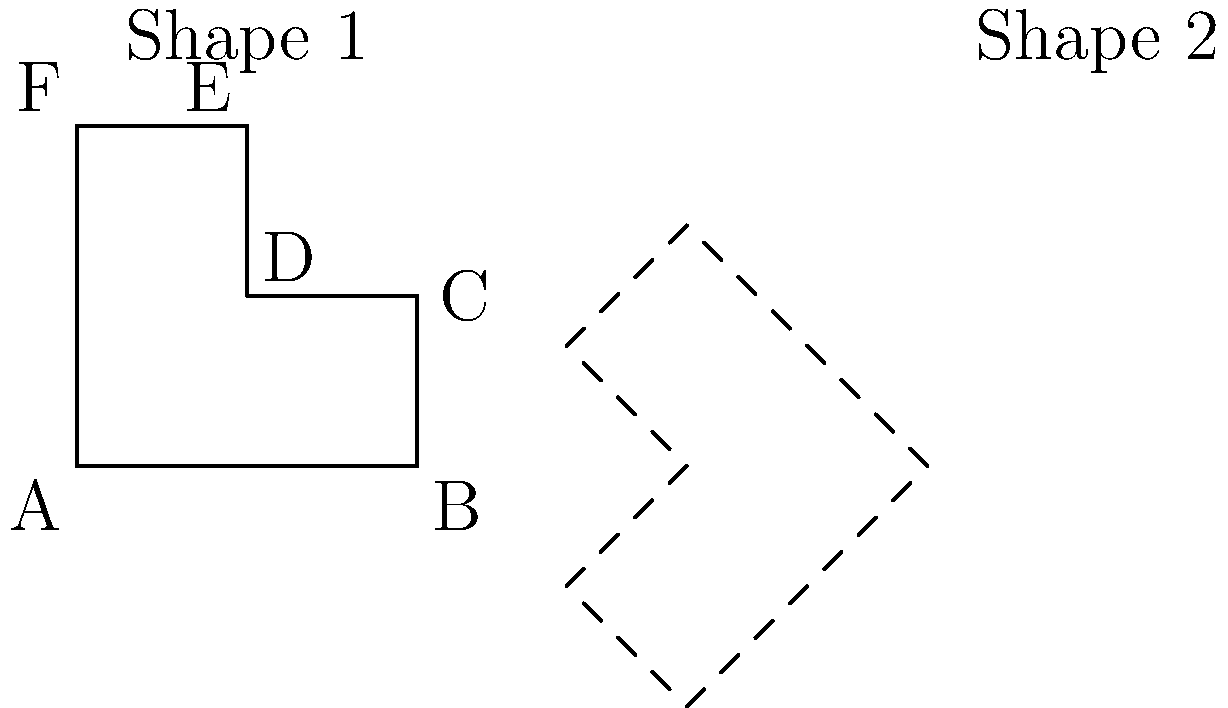Shape 1 is rotated to create Shape 2. What is the angle of rotation in degrees? To determine the angle of rotation, let's follow these steps:

1. Observe the orientation of both shapes. Shape 1 is upright, while Shape 2 is rotated counterclockwise.

2. Look for a key feature that can help identify the rotation. In this case, the long edge of the shape (side AB in Shape 1) is a good reference.

3. In Shape 1, side AB is horizontal. In Shape 2, this side is now diagonal, pointing towards the upper-left corner.

4. The rotation that transforms a horizontal line to a diagonal line pointing up and left is 135°.

5. To verify, we can check other features:
   - The right angle at point A in Shape 1 is now at the bottom-right corner of Shape 2.
   - The "step" feature (CDE) in Shape 1 is now at the top-right of Shape 2.

These observations confirm that a 135° counterclockwise rotation was applied.

Remember, in geometry, counterclockwise rotations are typically considered positive, so we don't need to specify the direction in our answer.
Answer: 135° 